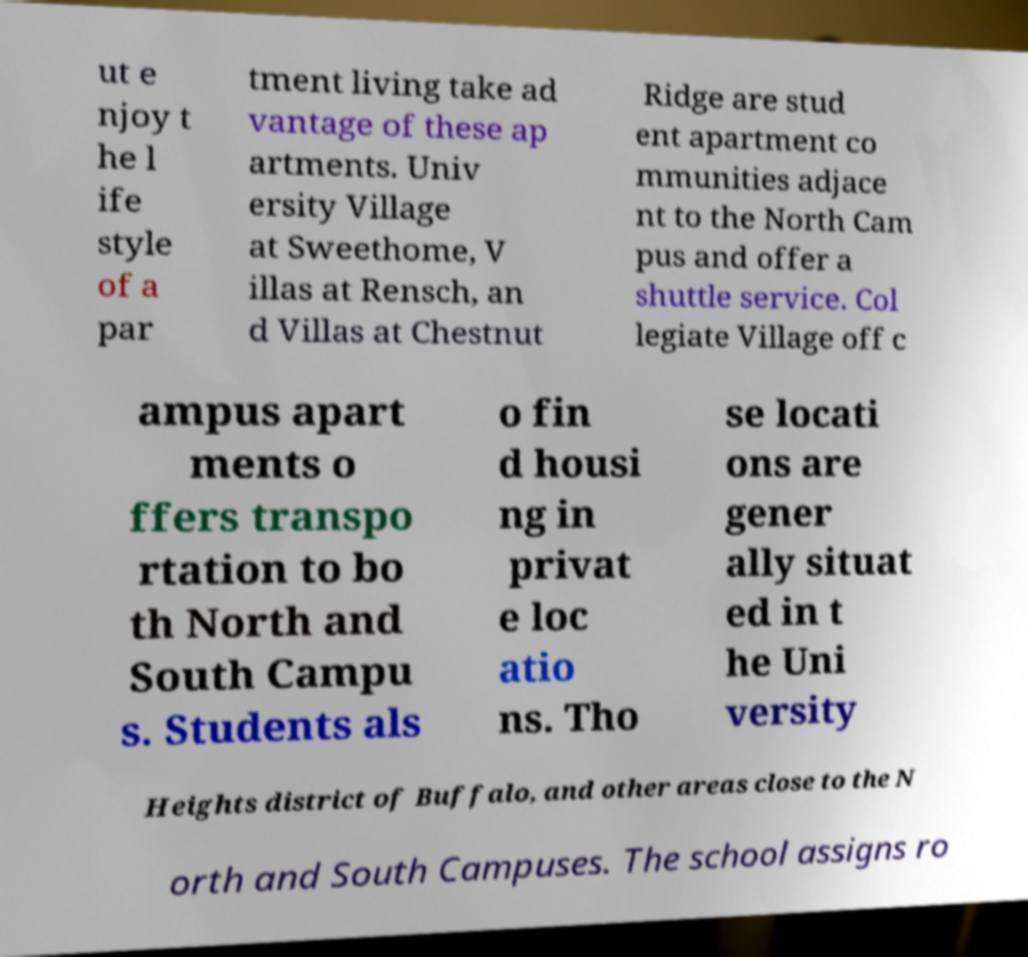Could you assist in decoding the text presented in this image and type it out clearly? ut e njoy t he l ife style of a par tment living take ad vantage of these ap artments. Univ ersity Village at Sweethome, V illas at Rensch, an d Villas at Chestnut Ridge are stud ent apartment co mmunities adjace nt to the North Cam pus and offer a shuttle service. Col legiate Village off c ampus apart ments o ffers transpo rtation to bo th North and South Campu s. Students als o fin d housi ng in privat e loc atio ns. Tho se locati ons are gener ally situat ed in t he Uni versity Heights district of Buffalo, and other areas close to the N orth and South Campuses. The school assigns ro 